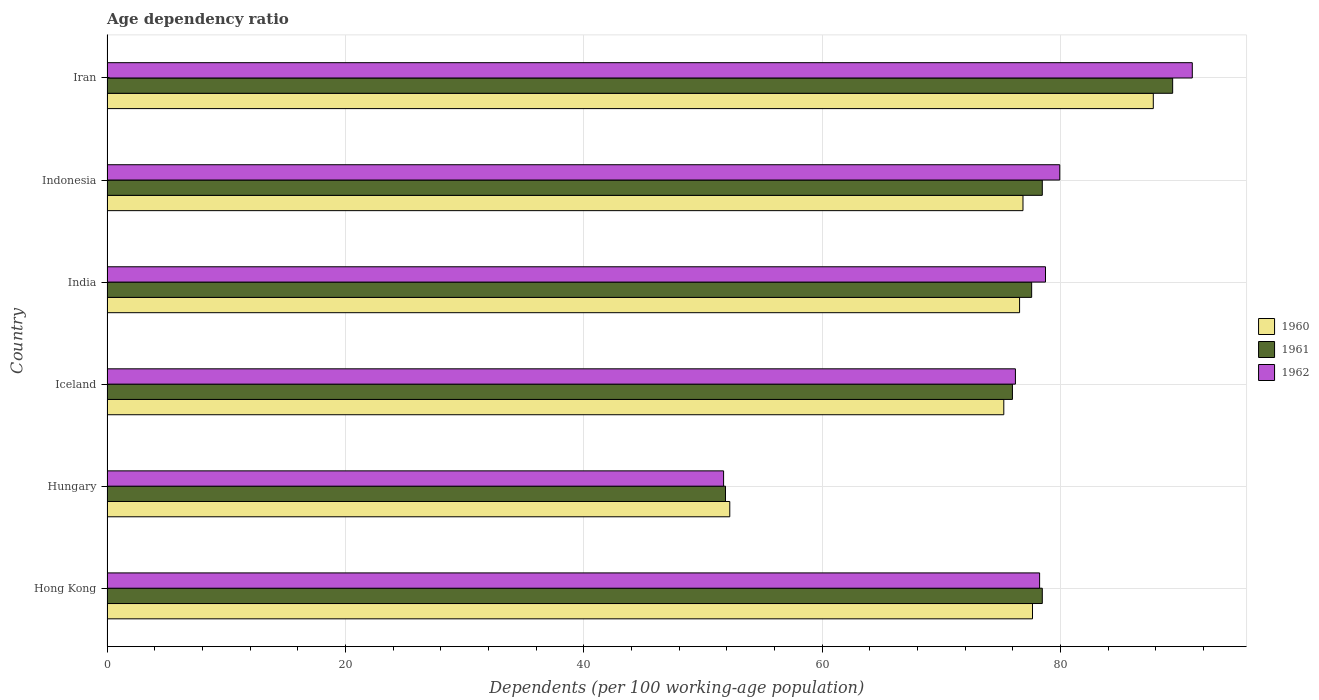Are the number of bars per tick equal to the number of legend labels?
Ensure brevity in your answer.  Yes. How many bars are there on the 6th tick from the top?
Keep it short and to the point. 3. How many bars are there on the 6th tick from the bottom?
Keep it short and to the point. 3. In how many cases, is the number of bars for a given country not equal to the number of legend labels?
Provide a short and direct response. 0. What is the age dependency ratio in in 1960 in Indonesia?
Your response must be concise. 76.85. Across all countries, what is the maximum age dependency ratio in in 1962?
Keep it short and to the point. 91.05. Across all countries, what is the minimum age dependency ratio in in 1960?
Provide a short and direct response. 52.25. In which country was the age dependency ratio in in 1960 maximum?
Your answer should be compact. Iran. In which country was the age dependency ratio in in 1962 minimum?
Keep it short and to the point. Hungary. What is the total age dependency ratio in in 1960 in the graph?
Your answer should be compact. 446.31. What is the difference between the age dependency ratio in in 1960 in Hong Kong and that in Iran?
Ensure brevity in your answer.  -10.13. What is the difference between the age dependency ratio in in 1960 in India and the age dependency ratio in in 1961 in Indonesia?
Provide a short and direct response. -1.91. What is the average age dependency ratio in in 1962 per country?
Offer a very short reply. 75.98. What is the difference between the age dependency ratio in in 1961 and age dependency ratio in in 1962 in Indonesia?
Keep it short and to the point. -1.47. What is the ratio of the age dependency ratio in in 1961 in Hong Kong to that in Indonesia?
Your response must be concise. 1. Is the difference between the age dependency ratio in in 1961 in Iceland and India greater than the difference between the age dependency ratio in in 1962 in Iceland and India?
Offer a very short reply. Yes. What is the difference between the highest and the second highest age dependency ratio in in 1962?
Your answer should be very brief. 11.12. What is the difference between the highest and the lowest age dependency ratio in in 1962?
Your response must be concise. 39.32. In how many countries, is the age dependency ratio in in 1962 greater than the average age dependency ratio in in 1962 taken over all countries?
Your answer should be compact. 5. Is it the case that in every country, the sum of the age dependency ratio in in 1962 and age dependency ratio in in 1961 is greater than the age dependency ratio in in 1960?
Provide a short and direct response. Yes. What is the difference between two consecutive major ticks on the X-axis?
Offer a very short reply. 20. Are the values on the major ticks of X-axis written in scientific E-notation?
Provide a succinct answer. No. Does the graph contain any zero values?
Give a very brief answer. No. Where does the legend appear in the graph?
Provide a short and direct response. Center right. How are the legend labels stacked?
Your response must be concise. Vertical. What is the title of the graph?
Offer a very short reply. Age dependency ratio. What is the label or title of the X-axis?
Make the answer very short. Dependents (per 100 working-age population). What is the label or title of the Y-axis?
Offer a terse response. Country. What is the Dependents (per 100 working-age population) of 1960 in Hong Kong?
Provide a short and direct response. 77.64. What is the Dependents (per 100 working-age population) of 1961 in Hong Kong?
Your response must be concise. 78.46. What is the Dependents (per 100 working-age population) of 1962 in Hong Kong?
Your answer should be compact. 78.24. What is the Dependents (per 100 working-age population) of 1960 in Hungary?
Keep it short and to the point. 52.25. What is the Dependents (per 100 working-age population) of 1961 in Hungary?
Offer a terse response. 51.89. What is the Dependents (per 100 working-age population) in 1962 in Hungary?
Provide a short and direct response. 51.73. What is the Dependents (per 100 working-age population) in 1960 in Iceland?
Your response must be concise. 75.24. What is the Dependents (per 100 working-age population) in 1961 in Iceland?
Offer a terse response. 75.96. What is the Dependents (per 100 working-age population) of 1962 in Iceland?
Your answer should be compact. 76.21. What is the Dependents (per 100 working-age population) in 1960 in India?
Ensure brevity in your answer.  76.56. What is the Dependents (per 100 working-age population) in 1961 in India?
Give a very brief answer. 77.57. What is the Dependents (per 100 working-age population) in 1962 in India?
Provide a short and direct response. 78.73. What is the Dependents (per 100 working-age population) of 1960 in Indonesia?
Your answer should be very brief. 76.85. What is the Dependents (per 100 working-age population) of 1961 in Indonesia?
Give a very brief answer. 78.47. What is the Dependents (per 100 working-age population) in 1962 in Indonesia?
Make the answer very short. 79.93. What is the Dependents (per 100 working-age population) of 1960 in Iran?
Give a very brief answer. 87.78. What is the Dependents (per 100 working-age population) of 1961 in Iran?
Give a very brief answer. 89.4. What is the Dependents (per 100 working-age population) of 1962 in Iran?
Provide a succinct answer. 91.05. Across all countries, what is the maximum Dependents (per 100 working-age population) in 1960?
Make the answer very short. 87.78. Across all countries, what is the maximum Dependents (per 100 working-age population) of 1961?
Make the answer very short. 89.4. Across all countries, what is the maximum Dependents (per 100 working-age population) of 1962?
Keep it short and to the point. 91.05. Across all countries, what is the minimum Dependents (per 100 working-age population) in 1960?
Your response must be concise. 52.25. Across all countries, what is the minimum Dependents (per 100 working-age population) in 1961?
Keep it short and to the point. 51.89. Across all countries, what is the minimum Dependents (per 100 working-age population) in 1962?
Ensure brevity in your answer.  51.73. What is the total Dependents (per 100 working-age population) of 1960 in the graph?
Provide a succinct answer. 446.31. What is the total Dependents (per 100 working-age population) of 1961 in the graph?
Make the answer very short. 451.75. What is the total Dependents (per 100 working-age population) of 1962 in the graph?
Make the answer very short. 455.89. What is the difference between the Dependents (per 100 working-age population) in 1960 in Hong Kong and that in Hungary?
Offer a terse response. 25.4. What is the difference between the Dependents (per 100 working-age population) in 1961 in Hong Kong and that in Hungary?
Your answer should be compact. 26.58. What is the difference between the Dependents (per 100 working-age population) in 1962 in Hong Kong and that in Hungary?
Keep it short and to the point. 26.51. What is the difference between the Dependents (per 100 working-age population) in 1960 in Hong Kong and that in Iceland?
Make the answer very short. 2.41. What is the difference between the Dependents (per 100 working-age population) of 1961 in Hong Kong and that in Iceland?
Offer a very short reply. 2.5. What is the difference between the Dependents (per 100 working-age population) of 1962 in Hong Kong and that in Iceland?
Your answer should be very brief. 2.03. What is the difference between the Dependents (per 100 working-age population) in 1960 in Hong Kong and that in India?
Offer a terse response. 1.08. What is the difference between the Dependents (per 100 working-age population) of 1961 in Hong Kong and that in India?
Give a very brief answer. 0.89. What is the difference between the Dependents (per 100 working-age population) of 1962 in Hong Kong and that in India?
Your answer should be very brief. -0.49. What is the difference between the Dependents (per 100 working-age population) in 1960 in Hong Kong and that in Indonesia?
Provide a short and direct response. 0.8. What is the difference between the Dependents (per 100 working-age population) of 1961 in Hong Kong and that in Indonesia?
Offer a very short reply. -0. What is the difference between the Dependents (per 100 working-age population) of 1962 in Hong Kong and that in Indonesia?
Give a very brief answer. -1.69. What is the difference between the Dependents (per 100 working-age population) of 1960 in Hong Kong and that in Iran?
Provide a short and direct response. -10.13. What is the difference between the Dependents (per 100 working-age population) in 1961 in Hong Kong and that in Iran?
Make the answer very short. -10.94. What is the difference between the Dependents (per 100 working-age population) of 1962 in Hong Kong and that in Iran?
Provide a short and direct response. -12.81. What is the difference between the Dependents (per 100 working-age population) of 1960 in Hungary and that in Iceland?
Offer a very short reply. -22.99. What is the difference between the Dependents (per 100 working-age population) of 1961 in Hungary and that in Iceland?
Your answer should be compact. -24.07. What is the difference between the Dependents (per 100 working-age population) in 1962 in Hungary and that in Iceland?
Your answer should be very brief. -24.48. What is the difference between the Dependents (per 100 working-age population) of 1960 in Hungary and that in India?
Offer a very short reply. -24.31. What is the difference between the Dependents (per 100 working-age population) of 1961 in Hungary and that in India?
Offer a terse response. -25.69. What is the difference between the Dependents (per 100 working-age population) in 1962 in Hungary and that in India?
Provide a succinct answer. -27.01. What is the difference between the Dependents (per 100 working-age population) of 1960 in Hungary and that in Indonesia?
Make the answer very short. -24.6. What is the difference between the Dependents (per 100 working-age population) of 1961 in Hungary and that in Indonesia?
Give a very brief answer. -26.58. What is the difference between the Dependents (per 100 working-age population) of 1962 in Hungary and that in Indonesia?
Your answer should be compact. -28.2. What is the difference between the Dependents (per 100 working-age population) of 1960 in Hungary and that in Iran?
Your answer should be compact. -35.53. What is the difference between the Dependents (per 100 working-age population) in 1961 in Hungary and that in Iran?
Your response must be concise. -37.51. What is the difference between the Dependents (per 100 working-age population) in 1962 in Hungary and that in Iran?
Ensure brevity in your answer.  -39.32. What is the difference between the Dependents (per 100 working-age population) of 1960 in Iceland and that in India?
Provide a succinct answer. -1.32. What is the difference between the Dependents (per 100 working-age population) in 1961 in Iceland and that in India?
Offer a very short reply. -1.61. What is the difference between the Dependents (per 100 working-age population) in 1962 in Iceland and that in India?
Your answer should be compact. -2.52. What is the difference between the Dependents (per 100 working-age population) of 1960 in Iceland and that in Indonesia?
Make the answer very short. -1.61. What is the difference between the Dependents (per 100 working-age population) of 1961 in Iceland and that in Indonesia?
Keep it short and to the point. -2.51. What is the difference between the Dependents (per 100 working-age population) of 1962 in Iceland and that in Indonesia?
Offer a very short reply. -3.72. What is the difference between the Dependents (per 100 working-age population) of 1960 in Iceland and that in Iran?
Give a very brief answer. -12.54. What is the difference between the Dependents (per 100 working-age population) in 1961 in Iceland and that in Iran?
Provide a short and direct response. -13.44. What is the difference between the Dependents (per 100 working-age population) of 1962 in Iceland and that in Iran?
Keep it short and to the point. -14.84. What is the difference between the Dependents (per 100 working-age population) of 1960 in India and that in Indonesia?
Your answer should be very brief. -0.29. What is the difference between the Dependents (per 100 working-age population) in 1961 in India and that in Indonesia?
Offer a terse response. -0.89. What is the difference between the Dependents (per 100 working-age population) in 1962 in India and that in Indonesia?
Keep it short and to the point. -1.2. What is the difference between the Dependents (per 100 working-age population) in 1960 in India and that in Iran?
Provide a short and direct response. -11.22. What is the difference between the Dependents (per 100 working-age population) in 1961 in India and that in Iran?
Your response must be concise. -11.83. What is the difference between the Dependents (per 100 working-age population) of 1962 in India and that in Iran?
Your answer should be compact. -12.31. What is the difference between the Dependents (per 100 working-age population) in 1960 in Indonesia and that in Iran?
Offer a terse response. -10.93. What is the difference between the Dependents (per 100 working-age population) of 1961 in Indonesia and that in Iran?
Ensure brevity in your answer.  -10.94. What is the difference between the Dependents (per 100 working-age population) of 1962 in Indonesia and that in Iran?
Give a very brief answer. -11.12. What is the difference between the Dependents (per 100 working-age population) in 1960 in Hong Kong and the Dependents (per 100 working-age population) in 1961 in Hungary?
Offer a terse response. 25.76. What is the difference between the Dependents (per 100 working-age population) of 1960 in Hong Kong and the Dependents (per 100 working-age population) of 1962 in Hungary?
Your answer should be very brief. 25.92. What is the difference between the Dependents (per 100 working-age population) of 1961 in Hong Kong and the Dependents (per 100 working-age population) of 1962 in Hungary?
Make the answer very short. 26.74. What is the difference between the Dependents (per 100 working-age population) of 1960 in Hong Kong and the Dependents (per 100 working-age population) of 1961 in Iceland?
Provide a succinct answer. 1.68. What is the difference between the Dependents (per 100 working-age population) in 1960 in Hong Kong and the Dependents (per 100 working-age population) in 1962 in Iceland?
Make the answer very short. 1.43. What is the difference between the Dependents (per 100 working-age population) of 1961 in Hong Kong and the Dependents (per 100 working-age population) of 1962 in Iceland?
Make the answer very short. 2.25. What is the difference between the Dependents (per 100 working-age population) of 1960 in Hong Kong and the Dependents (per 100 working-age population) of 1961 in India?
Your response must be concise. 0.07. What is the difference between the Dependents (per 100 working-age population) of 1960 in Hong Kong and the Dependents (per 100 working-age population) of 1962 in India?
Your answer should be very brief. -1.09. What is the difference between the Dependents (per 100 working-age population) of 1961 in Hong Kong and the Dependents (per 100 working-age population) of 1962 in India?
Offer a very short reply. -0.27. What is the difference between the Dependents (per 100 working-age population) of 1960 in Hong Kong and the Dependents (per 100 working-age population) of 1961 in Indonesia?
Offer a very short reply. -0.82. What is the difference between the Dependents (per 100 working-age population) of 1960 in Hong Kong and the Dependents (per 100 working-age population) of 1962 in Indonesia?
Provide a short and direct response. -2.29. What is the difference between the Dependents (per 100 working-age population) of 1961 in Hong Kong and the Dependents (per 100 working-age population) of 1962 in Indonesia?
Your response must be concise. -1.47. What is the difference between the Dependents (per 100 working-age population) of 1960 in Hong Kong and the Dependents (per 100 working-age population) of 1961 in Iran?
Your response must be concise. -11.76. What is the difference between the Dependents (per 100 working-age population) of 1960 in Hong Kong and the Dependents (per 100 working-age population) of 1962 in Iran?
Ensure brevity in your answer.  -13.41. What is the difference between the Dependents (per 100 working-age population) in 1961 in Hong Kong and the Dependents (per 100 working-age population) in 1962 in Iran?
Your answer should be very brief. -12.58. What is the difference between the Dependents (per 100 working-age population) of 1960 in Hungary and the Dependents (per 100 working-age population) of 1961 in Iceland?
Your answer should be very brief. -23.71. What is the difference between the Dependents (per 100 working-age population) of 1960 in Hungary and the Dependents (per 100 working-age population) of 1962 in Iceland?
Give a very brief answer. -23.96. What is the difference between the Dependents (per 100 working-age population) in 1961 in Hungary and the Dependents (per 100 working-age population) in 1962 in Iceland?
Provide a short and direct response. -24.32. What is the difference between the Dependents (per 100 working-age population) in 1960 in Hungary and the Dependents (per 100 working-age population) in 1961 in India?
Offer a terse response. -25.33. What is the difference between the Dependents (per 100 working-age population) in 1960 in Hungary and the Dependents (per 100 working-age population) in 1962 in India?
Your answer should be very brief. -26.49. What is the difference between the Dependents (per 100 working-age population) in 1961 in Hungary and the Dependents (per 100 working-age population) in 1962 in India?
Provide a short and direct response. -26.85. What is the difference between the Dependents (per 100 working-age population) in 1960 in Hungary and the Dependents (per 100 working-age population) in 1961 in Indonesia?
Offer a terse response. -26.22. What is the difference between the Dependents (per 100 working-age population) in 1960 in Hungary and the Dependents (per 100 working-age population) in 1962 in Indonesia?
Your answer should be very brief. -27.68. What is the difference between the Dependents (per 100 working-age population) in 1961 in Hungary and the Dependents (per 100 working-age population) in 1962 in Indonesia?
Provide a succinct answer. -28.04. What is the difference between the Dependents (per 100 working-age population) of 1960 in Hungary and the Dependents (per 100 working-age population) of 1961 in Iran?
Keep it short and to the point. -37.15. What is the difference between the Dependents (per 100 working-age population) in 1960 in Hungary and the Dependents (per 100 working-age population) in 1962 in Iran?
Keep it short and to the point. -38.8. What is the difference between the Dependents (per 100 working-age population) in 1961 in Hungary and the Dependents (per 100 working-age population) in 1962 in Iran?
Provide a succinct answer. -39.16. What is the difference between the Dependents (per 100 working-age population) of 1960 in Iceland and the Dependents (per 100 working-age population) of 1961 in India?
Provide a short and direct response. -2.34. What is the difference between the Dependents (per 100 working-age population) in 1960 in Iceland and the Dependents (per 100 working-age population) in 1962 in India?
Ensure brevity in your answer.  -3.5. What is the difference between the Dependents (per 100 working-age population) of 1961 in Iceland and the Dependents (per 100 working-age population) of 1962 in India?
Keep it short and to the point. -2.77. What is the difference between the Dependents (per 100 working-age population) in 1960 in Iceland and the Dependents (per 100 working-age population) in 1961 in Indonesia?
Make the answer very short. -3.23. What is the difference between the Dependents (per 100 working-age population) in 1960 in Iceland and the Dependents (per 100 working-age population) in 1962 in Indonesia?
Your answer should be very brief. -4.7. What is the difference between the Dependents (per 100 working-age population) of 1961 in Iceland and the Dependents (per 100 working-age population) of 1962 in Indonesia?
Your answer should be very brief. -3.97. What is the difference between the Dependents (per 100 working-age population) in 1960 in Iceland and the Dependents (per 100 working-age population) in 1961 in Iran?
Provide a short and direct response. -14.17. What is the difference between the Dependents (per 100 working-age population) in 1960 in Iceland and the Dependents (per 100 working-age population) in 1962 in Iran?
Your response must be concise. -15.81. What is the difference between the Dependents (per 100 working-age population) in 1961 in Iceland and the Dependents (per 100 working-age population) in 1962 in Iran?
Offer a terse response. -15.09. What is the difference between the Dependents (per 100 working-age population) in 1960 in India and the Dependents (per 100 working-age population) in 1961 in Indonesia?
Provide a succinct answer. -1.91. What is the difference between the Dependents (per 100 working-age population) in 1960 in India and the Dependents (per 100 working-age population) in 1962 in Indonesia?
Your answer should be very brief. -3.37. What is the difference between the Dependents (per 100 working-age population) of 1961 in India and the Dependents (per 100 working-age population) of 1962 in Indonesia?
Make the answer very short. -2.36. What is the difference between the Dependents (per 100 working-age population) of 1960 in India and the Dependents (per 100 working-age population) of 1961 in Iran?
Your response must be concise. -12.84. What is the difference between the Dependents (per 100 working-age population) of 1960 in India and the Dependents (per 100 working-age population) of 1962 in Iran?
Offer a very short reply. -14.49. What is the difference between the Dependents (per 100 working-age population) of 1961 in India and the Dependents (per 100 working-age population) of 1962 in Iran?
Your response must be concise. -13.48. What is the difference between the Dependents (per 100 working-age population) in 1960 in Indonesia and the Dependents (per 100 working-age population) in 1961 in Iran?
Your response must be concise. -12.56. What is the difference between the Dependents (per 100 working-age population) of 1960 in Indonesia and the Dependents (per 100 working-age population) of 1962 in Iran?
Make the answer very short. -14.2. What is the difference between the Dependents (per 100 working-age population) of 1961 in Indonesia and the Dependents (per 100 working-age population) of 1962 in Iran?
Make the answer very short. -12.58. What is the average Dependents (per 100 working-age population) of 1960 per country?
Provide a succinct answer. 74.38. What is the average Dependents (per 100 working-age population) of 1961 per country?
Your response must be concise. 75.29. What is the average Dependents (per 100 working-age population) in 1962 per country?
Keep it short and to the point. 75.98. What is the difference between the Dependents (per 100 working-age population) in 1960 and Dependents (per 100 working-age population) in 1961 in Hong Kong?
Give a very brief answer. -0.82. What is the difference between the Dependents (per 100 working-age population) in 1960 and Dependents (per 100 working-age population) in 1962 in Hong Kong?
Make the answer very short. -0.6. What is the difference between the Dependents (per 100 working-age population) of 1961 and Dependents (per 100 working-age population) of 1962 in Hong Kong?
Offer a very short reply. 0.22. What is the difference between the Dependents (per 100 working-age population) of 1960 and Dependents (per 100 working-age population) of 1961 in Hungary?
Your response must be concise. 0.36. What is the difference between the Dependents (per 100 working-age population) in 1960 and Dependents (per 100 working-age population) in 1962 in Hungary?
Offer a terse response. 0.52. What is the difference between the Dependents (per 100 working-age population) of 1961 and Dependents (per 100 working-age population) of 1962 in Hungary?
Keep it short and to the point. 0.16. What is the difference between the Dependents (per 100 working-age population) of 1960 and Dependents (per 100 working-age population) of 1961 in Iceland?
Provide a succinct answer. -0.72. What is the difference between the Dependents (per 100 working-age population) of 1960 and Dependents (per 100 working-age population) of 1962 in Iceland?
Keep it short and to the point. -0.97. What is the difference between the Dependents (per 100 working-age population) of 1961 and Dependents (per 100 working-age population) of 1962 in Iceland?
Keep it short and to the point. -0.25. What is the difference between the Dependents (per 100 working-age population) of 1960 and Dependents (per 100 working-age population) of 1961 in India?
Provide a short and direct response. -1.01. What is the difference between the Dependents (per 100 working-age population) of 1960 and Dependents (per 100 working-age population) of 1962 in India?
Offer a terse response. -2.17. What is the difference between the Dependents (per 100 working-age population) of 1961 and Dependents (per 100 working-age population) of 1962 in India?
Ensure brevity in your answer.  -1.16. What is the difference between the Dependents (per 100 working-age population) in 1960 and Dependents (per 100 working-age population) in 1961 in Indonesia?
Your answer should be very brief. -1.62. What is the difference between the Dependents (per 100 working-age population) in 1960 and Dependents (per 100 working-age population) in 1962 in Indonesia?
Offer a very short reply. -3.09. What is the difference between the Dependents (per 100 working-age population) of 1961 and Dependents (per 100 working-age population) of 1962 in Indonesia?
Offer a very short reply. -1.47. What is the difference between the Dependents (per 100 working-age population) in 1960 and Dependents (per 100 working-age population) in 1961 in Iran?
Ensure brevity in your answer.  -1.62. What is the difference between the Dependents (per 100 working-age population) of 1960 and Dependents (per 100 working-age population) of 1962 in Iran?
Offer a very short reply. -3.27. What is the difference between the Dependents (per 100 working-age population) of 1961 and Dependents (per 100 working-age population) of 1962 in Iran?
Make the answer very short. -1.65. What is the ratio of the Dependents (per 100 working-age population) of 1960 in Hong Kong to that in Hungary?
Give a very brief answer. 1.49. What is the ratio of the Dependents (per 100 working-age population) in 1961 in Hong Kong to that in Hungary?
Provide a succinct answer. 1.51. What is the ratio of the Dependents (per 100 working-age population) of 1962 in Hong Kong to that in Hungary?
Make the answer very short. 1.51. What is the ratio of the Dependents (per 100 working-age population) in 1960 in Hong Kong to that in Iceland?
Keep it short and to the point. 1.03. What is the ratio of the Dependents (per 100 working-age population) of 1961 in Hong Kong to that in Iceland?
Your answer should be compact. 1.03. What is the ratio of the Dependents (per 100 working-age population) in 1962 in Hong Kong to that in Iceland?
Make the answer very short. 1.03. What is the ratio of the Dependents (per 100 working-age population) in 1960 in Hong Kong to that in India?
Keep it short and to the point. 1.01. What is the ratio of the Dependents (per 100 working-age population) of 1961 in Hong Kong to that in India?
Offer a very short reply. 1.01. What is the ratio of the Dependents (per 100 working-age population) in 1962 in Hong Kong to that in India?
Provide a short and direct response. 0.99. What is the ratio of the Dependents (per 100 working-age population) in 1960 in Hong Kong to that in Indonesia?
Your response must be concise. 1.01. What is the ratio of the Dependents (per 100 working-age population) of 1961 in Hong Kong to that in Indonesia?
Your answer should be very brief. 1. What is the ratio of the Dependents (per 100 working-age population) in 1962 in Hong Kong to that in Indonesia?
Keep it short and to the point. 0.98. What is the ratio of the Dependents (per 100 working-age population) of 1960 in Hong Kong to that in Iran?
Ensure brevity in your answer.  0.88. What is the ratio of the Dependents (per 100 working-age population) in 1961 in Hong Kong to that in Iran?
Offer a very short reply. 0.88. What is the ratio of the Dependents (per 100 working-age population) in 1962 in Hong Kong to that in Iran?
Offer a very short reply. 0.86. What is the ratio of the Dependents (per 100 working-age population) in 1960 in Hungary to that in Iceland?
Provide a short and direct response. 0.69. What is the ratio of the Dependents (per 100 working-age population) in 1961 in Hungary to that in Iceland?
Keep it short and to the point. 0.68. What is the ratio of the Dependents (per 100 working-age population) of 1962 in Hungary to that in Iceland?
Make the answer very short. 0.68. What is the ratio of the Dependents (per 100 working-age population) of 1960 in Hungary to that in India?
Give a very brief answer. 0.68. What is the ratio of the Dependents (per 100 working-age population) of 1961 in Hungary to that in India?
Offer a very short reply. 0.67. What is the ratio of the Dependents (per 100 working-age population) of 1962 in Hungary to that in India?
Provide a short and direct response. 0.66. What is the ratio of the Dependents (per 100 working-age population) of 1960 in Hungary to that in Indonesia?
Your answer should be compact. 0.68. What is the ratio of the Dependents (per 100 working-age population) of 1961 in Hungary to that in Indonesia?
Your response must be concise. 0.66. What is the ratio of the Dependents (per 100 working-age population) of 1962 in Hungary to that in Indonesia?
Provide a succinct answer. 0.65. What is the ratio of the Dependents (per 100 working-age population) of 1960 in Hungary to that in Iran?
Keep it short and to the point. 0.6. What is the ratio of the Dependents (per 100 working-age population) in 1961 in Hungary to that in Iran?
Your response must be concise. 0.58. What is the ratio of the Dependents (per 100 working-age population) of 1962 in Hungary to that in Iran?
Your response must be concise. 0.57. What is the ratio of the Dependents (per 100 working-age population) of 1960 in Iceland to that in India?
Keep it short and to the point. 0.98. What is the ratio of the Dependents (per 100 working-age population) in 1961 in Iceland to that in India?
Keep it short and to the point. 0.98. What is the ratio of the Dependents (per 100 working-age population) of 1962 in Iceland to that in India?
Your response must be concise. 0.97. What is the ratio of the Dependents (per 100 working-age population) in 1960 in Iceland to that in Indonesia?
Ensure brevity in your answer.  0.98. What is the ratio of the Dependents (per 100 working-age population) of 1961 in Iceland to that in Indonesia?
Your answer should be very brief. 0.97. What is the ratio of the Dependents (per 100 working-age population) in 1962 in Iceland to that in Indonesia?
Make the answer very short. 0.95. What is the ratio of the Dependents (per 100 working-age population) of 1960 in Iceland to that in Iran?
Make the answer very short. 0.86. What is the ratio of the Dependents (per 100 working-age population) in 1961 in Iceland to that in Iran?
Your response must be concise. 0.85. What is the ratio of the Dependents (per 100 working-age population) in 1962 in Iceland to that in Iran?
Your response must be concise. 0.84. What is the ratio of the Dependents (per 100 working-age population) in 1960 in India to that in Indonesia?
Offer a very short reply. 1. What is the ratio of the Dependents (per 100 working-age population) in 1962 in India to that in Indonesia?
Offer a very short reply. 0.98. What is the ratio of the Dependents (per 100 working-age population) in 1960 in India to that in Iran?
Your response must be concise. 0.87. What is the ratio of the Dependents (per 100 working-age population) of 1961 in India to that in Iran?
Provide a succinct answer. 0.87. What is the ratio of the Dependents (per 100 working-age population) of 1962 in India to that in Iran?
Make the answer very short. 0.86. What is the ratio of the Dependents (per 100 working-age population) in 1960 in Indonesia to that in Iran?
Ensure brevity in your answer.  0.88. What is the ratio of the Dependents (per 100 working-age population) in 1961 in Indonesia to that in Iran?
Make the answer very short. 0.88. What is the ratio of the Dependents (per 100 working-age population) in 1962 in Indonesia to that in Iran?
Your answer should be compact. 0.88. What is the difference between the highest and the second highest Dependents (per 100 working-age population) in 1960?
Offer a terse response. 10.13. What is the difference between the highest and the second highest Dependents (per 100 working-age population) of 1961?
Your answer should be compact. 10.94. What is the difference between the highest and the second highest Dependents (per 100 working-age population) in 1962?
Give a very brief answer. 11.12. What is the difference between the highest and the lowest Dependents (per 100 working-age population) of 1960?
Ensure brevity in your answer.  35.53. What is the difference between the highest and the lowest Dependents (per 100 working-age population) in 1961?
Ensure brevity in your answer.  37.51. What is the difference between the highest and the lowest Dependents (per 100 working-age population) of 1962?
Provide a succinct answer. 39.32. 